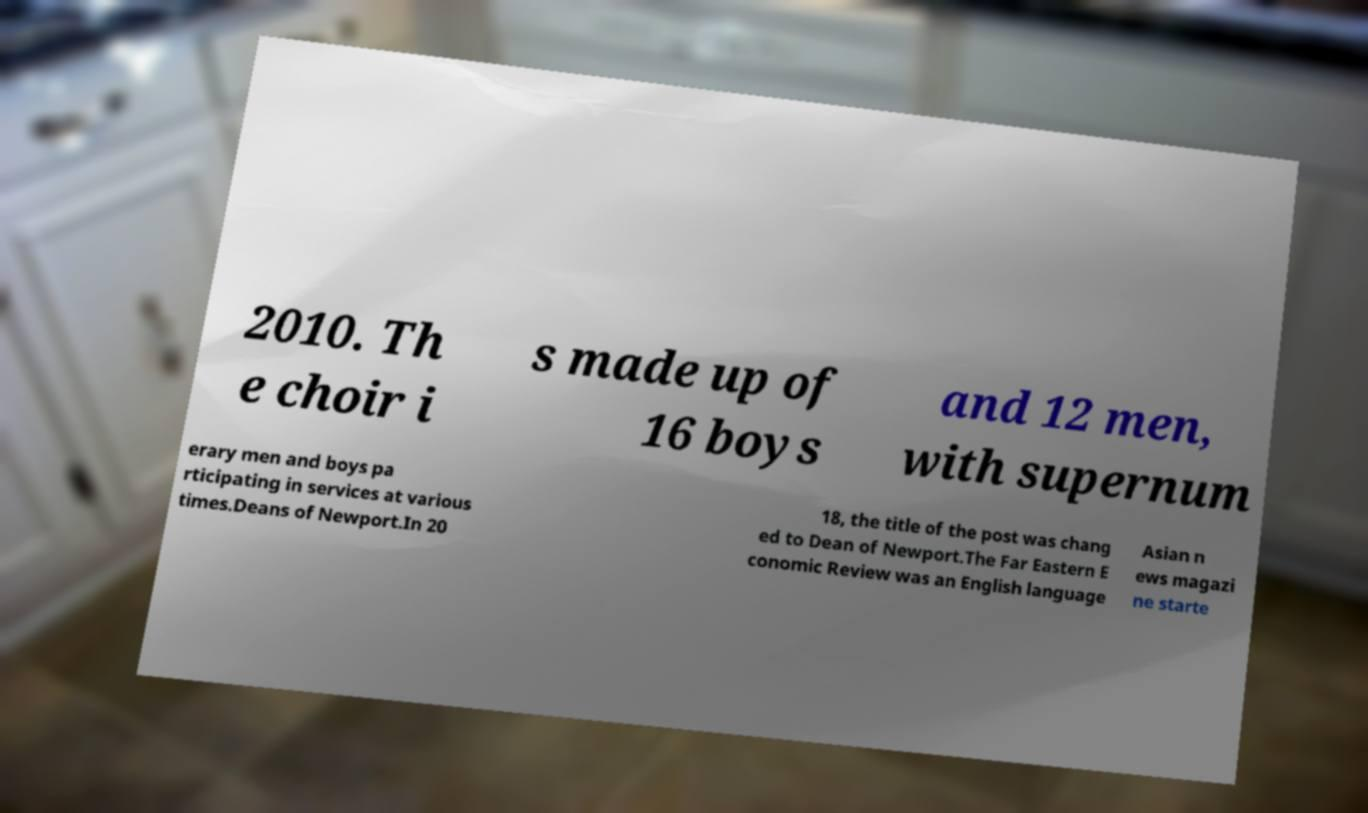Please read and relay the text visible in this image. What does it say? 2010. Th e choir i s made up of 16 boys and 12 men, with supernum erary men and boys pa rticipating in services at various times.Deans of Newport.In 20 18, the title of the post was chang ed to Dean of Newport.The Far Eastern E conomic Review was an English language Asian n ews magazi ne starte 